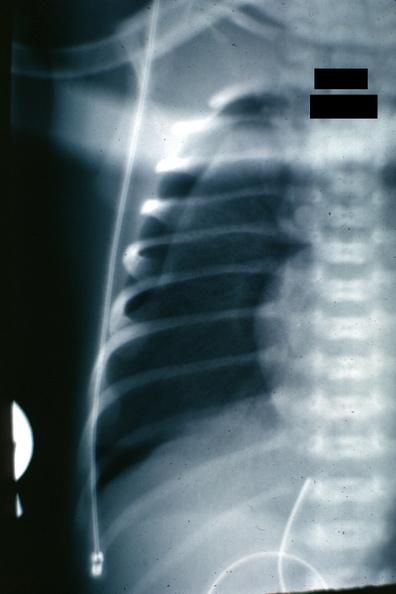s pneumothorax x-ray infant present?
Answer the question using a single word or phrase. Yes 